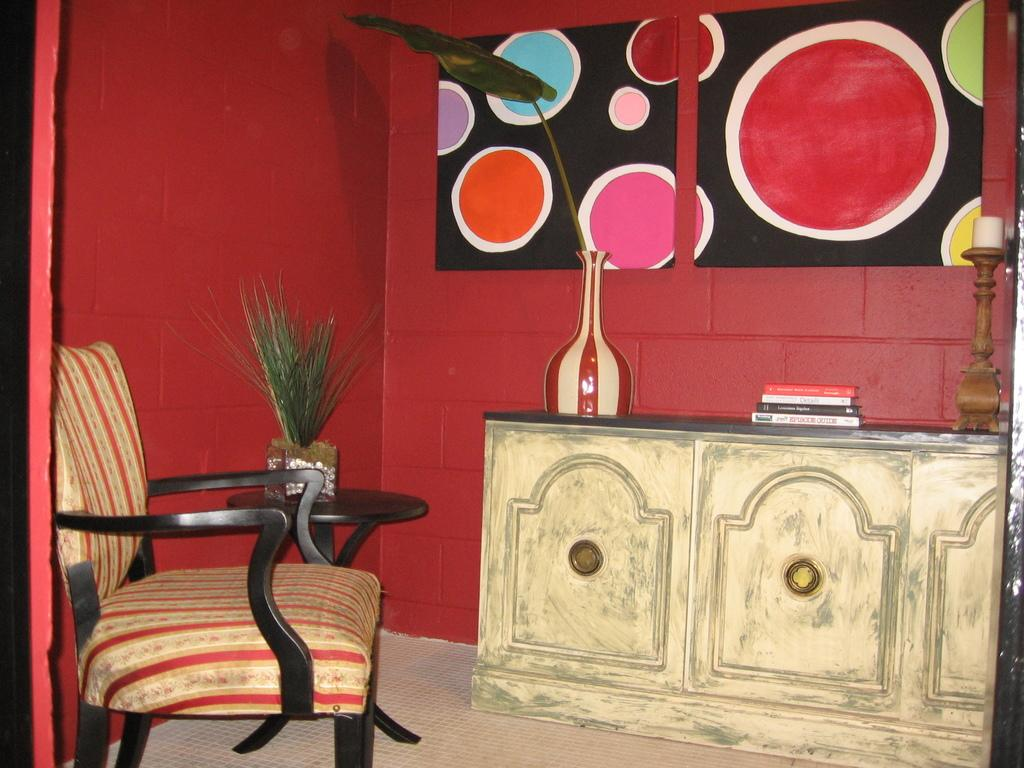What type of furniture is present in the image? There is a chair and a table in the image. What is placed on the table? There are books on the table. What other objects can be seen in the image? There is a plant, a wall, and a frame in the background of the image. What is the surface on which the furniture and objects are placed? There is a floor visible in the image. What type of news can be heard coming from the cave in the image? There is no cave present in the image, so it's not possible to determine what, if any, news might be heard. 